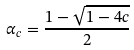Convert formula to latex. <formula><loc_0><loc_0><loc_500><loc_500>\alpha _ { c } = \frac { 1 - \sqrt { 1 - 4 c } } { 2 }</formula> 